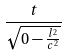<formula> <loc_0><loc_0><loc_500><loc_500>\frac { t } { \sqrt { 0 - \frac { l ^ { 2 } } { c ^ { 2 } } } }</formula> 